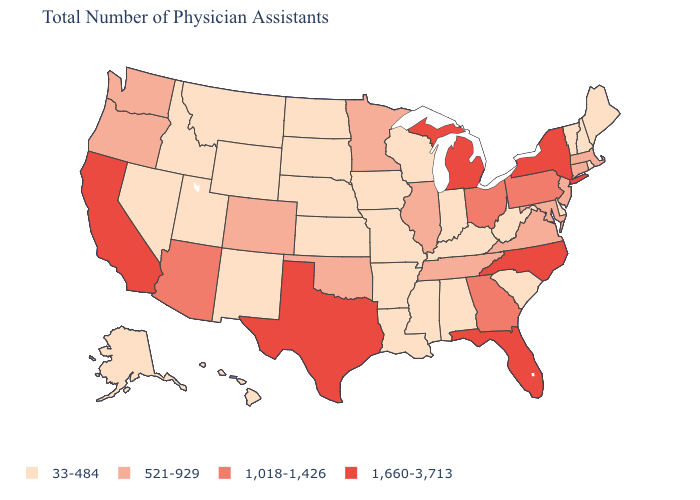Which states hav the highest value in the Northeast?
Be succinct. New York. What is the value of Texas?
Concise answer only. 1,660-3,713. Does Florida have the highest value in the USA?
Answer briefly. Yes. What is the value of Utah?
Keep it brief. 33-484. Does Iowa have a lower value than West Virginia?
Concise answer only. No. Is the legend a continuous bar?
Write a very short answer. No. Name the states that have a value in the range 1,018-1,426?
Write a very short answer. Arizona, Georgia, Ohio, Pennsylvania. Which states hav the highest value in the South?
Answer briefly. Florida, North Carolina, Texas. Among the states that border Connecticut , which have the highest value?
Quick response, please. New York. What is the lowest value in states that border Texas?
Concise answer only. 33-484. What is the highest value in states that border Vermont?
Write a very short answer. 1,660-3,713. What is the lowest value in the USA?
Concise answer only. 33-484. Does Kansas have the lowest value in the USA?
Give a very brief answer. Yes. Among the states that border Florida , which have the highest value?
Give a very brief answer. Georgia. Name the states that have a value in the range 521-929?
Concise answer only. Colorado, Connecticut, Illinois, Maryland, Massachusetts, Minnesota, New Jersey, Oklahoma, Oregon, Tennessee, Virginia, Washington. 